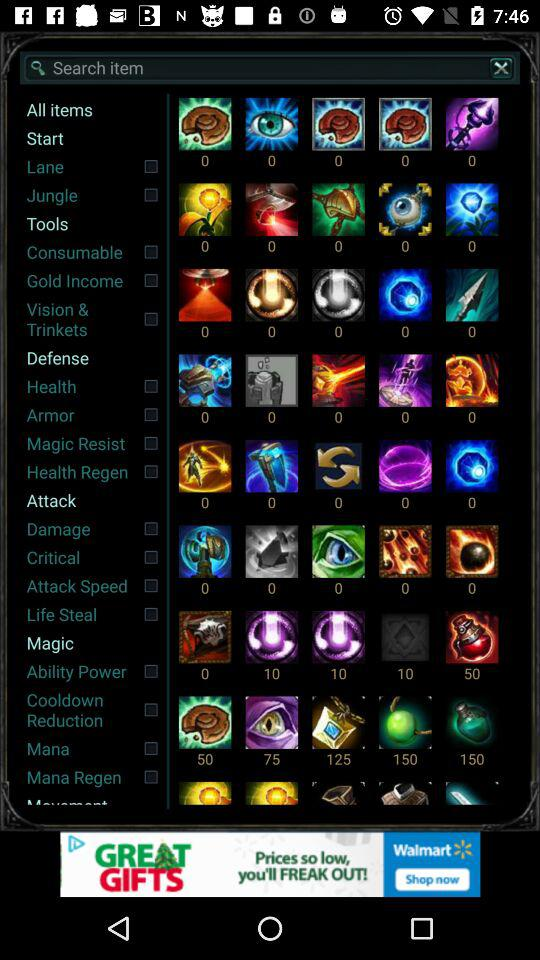Which items are selected?
When the provided information is insufficient, respond with <no answer>. <no answer> 